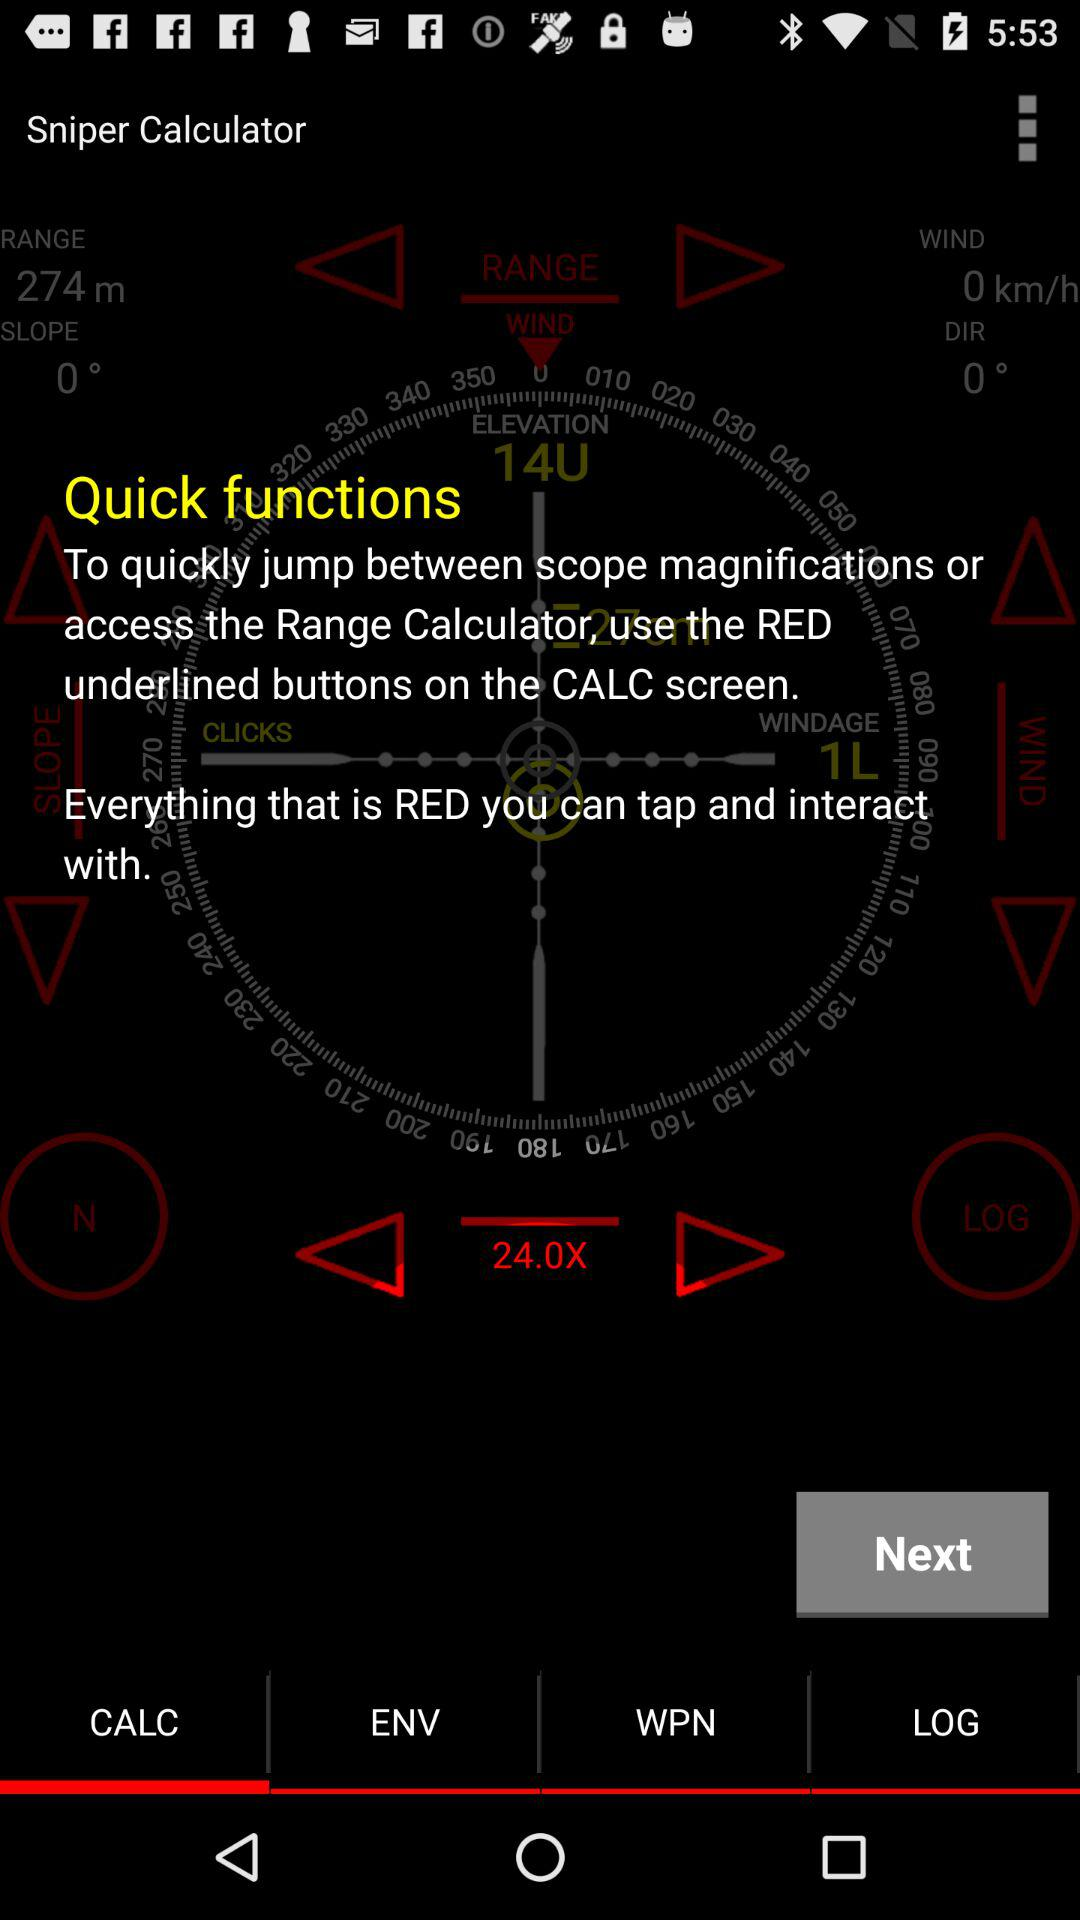Which option is selected? The selected option is "CALC". 